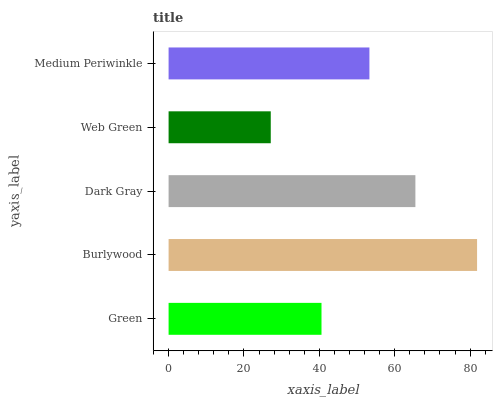Is Web Green the minimum?
Answer yes or no. Yes. Is Burlywood the maximum?
Answer yes or no. Yes. Is Dark Gray the minimum?
Answer yes or no. No. Is Dark Gray the maximum?
Answer yes or no. No. Is Burlywood greater than Dark Gray?
Answer yes or no. Yes. Is Dark Gray less than Burlywood?
Answer yes or no. Yes. Is Dark Gray greater than Burlywood?
Answer yes or no. No. Is Burlywood less than Dark Gray?
Answer yes or no. No. Is Medium Periwinkle the high median?
Answer yes or no. Yes. Is Medium Periwinkle the low median?
Answer yes or no. Yes. Is Burlywood the high median?
Answer yes or no. No. Is Web Green the low median?
Answer yes or no. No. 